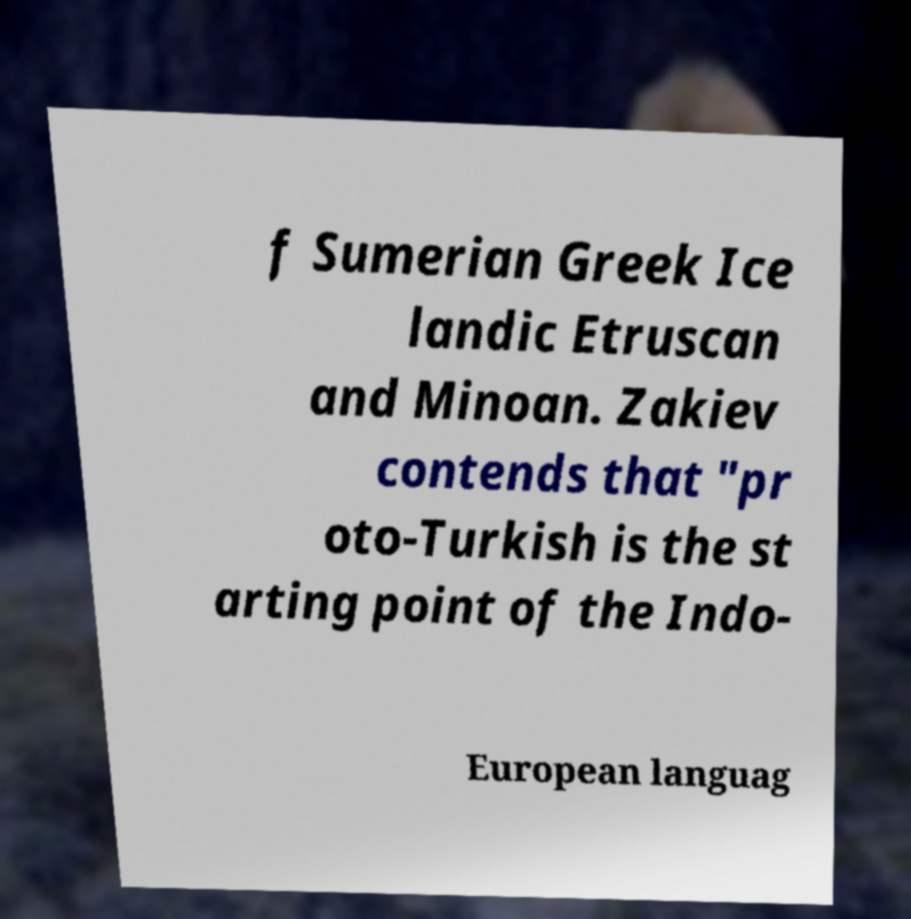Please read and relay the text visible in this image. What does it say? f Sumerian Greek Ice landic Etruscan and Minoan. Zakiev contends that "pr oto-Turkish is the st arting point of the Indo- European languag 